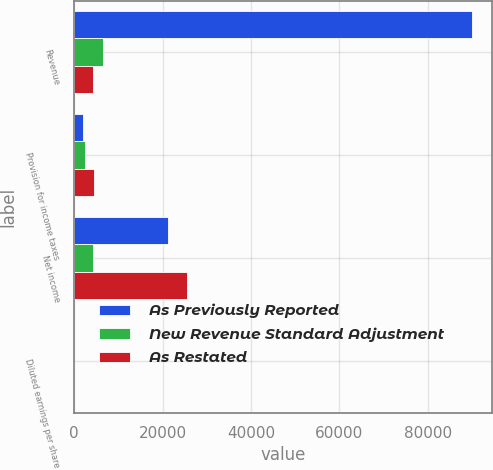Convert chart to OTSL. <chart><loc_0><loc_0><loc_500><loc_500><stacked_bar_chart><ecel><fcel>Revenue<fcel>Provision for income taxes<fcel>Net income<fcel>Diluted earnings per share<nl><fcel>As Previously Reported<fcel>89950<fcel>1945<fcel>21204<fcel>2.71<nl><fcel>New Revenue Standard Adjustment<fcel>6621<fcel>2467<fcel>4285<fcel>0.54<nl><fcel>As Restated<fcel>4285<fcel>4412<fcel>25489<fcel>3.25<nl></chart> 